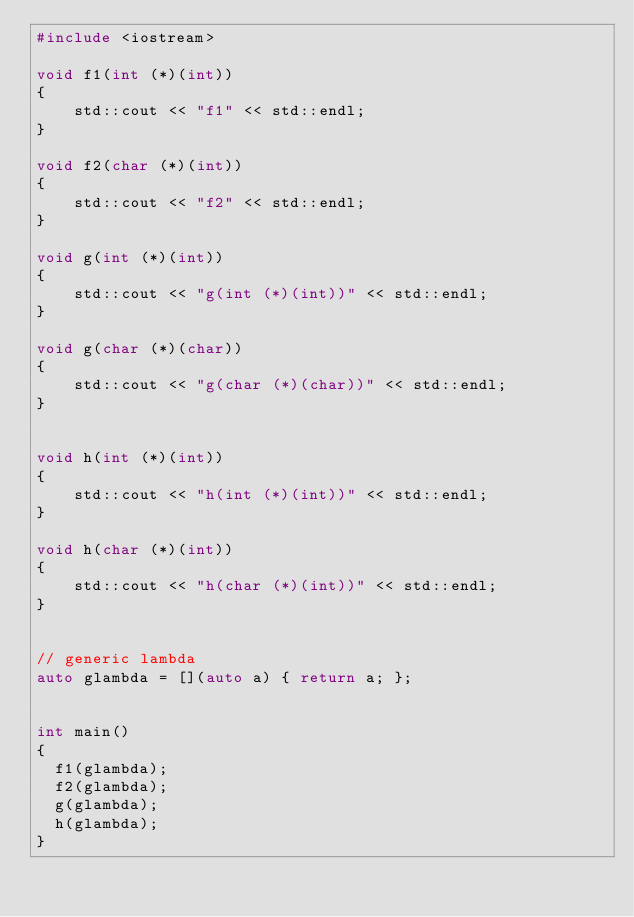Convert code to text. <code><loc_0><loc_0><loc_500><loc_500><_C++_>#include <iostream>

void f1(int (*)(int))   
{ 
    std::cout << "f1" << std::endl;
}

void f2(char (*)(int))  
{ 
    std::cout << "f2" << std::endl;
}

void g(int (*)(int))    
{ 
    std::cout << "g(int (*)(int))" << std::endl;
}  

void g(char (*)(char))  
{ 
    std::cout << "g(char (*)(char))" << std::endl;
}  


void h(int (*)(int))    
{ 
    std::cout << "h(int (*)(int))" << std::endl;
} 

void h(char (*)(int))   
{ 
    std::cout << "h(char (*)(int))" << std::endl;
}   
 

// generic lambda
auto glambda = [](auto a) { return a; };


int main()
{
  f1(glambda);   
  f2(glambda);   
  g(glambda);   
  h(glambda);   
}
</code> 